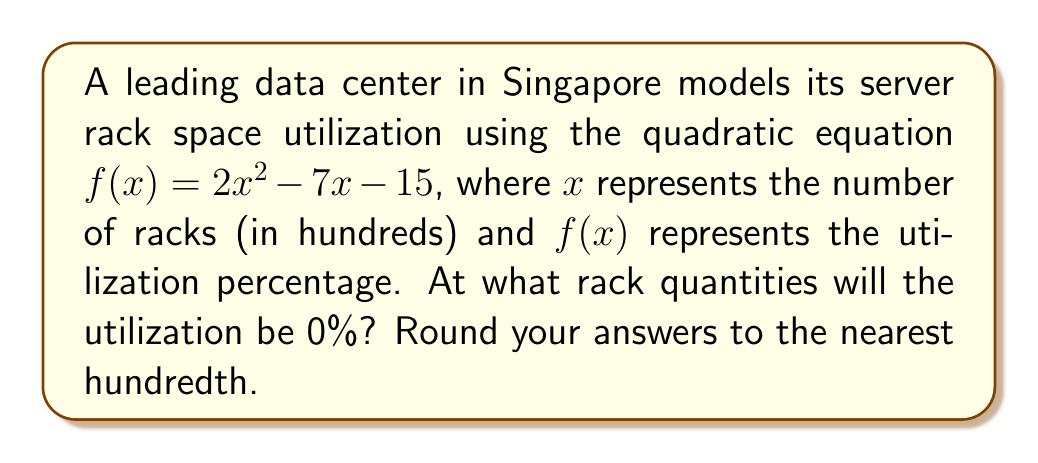Provide a solution to this math problem. To find the rack quantities where utilization is 0%, we need to find the roots of the quadratic equation $f(x) = 0$.

Step 1: Set up the equation
$$2x^2 - 7x - 15 = 0$$

Step 2: Use the quadratic formula $x = \frac{-b \pm \sqrt{b^2 - 4ac}}{2a}$
Where $a = 2$, $b = -7$, and $c = -15$

Step 3: Substitute into the quadratic formula
$$x = \frac{-(-7) \pm \sqrt{(-7)^2 - 4(2)(-15)}}{2(2)}$$

Step 4: Simplify
$$x = \frac{7 \pm \sqrt{49 + 120}}{4} = \frac{7 \pm \sqrt{169}}{4} = \frac{7 \pm 13}{4}$$

Step 5: Calculate the two roots
$$x_1 = \frac{7 + 13}{4} = \frac{20}{4} = 5$$
$$x_2 = \frac{7 - 13}{4} = -\frac{6}{4} = -1.5$$

Step 6: Interpret the results
The positive root (5) represents 500 racks, while the negative root (-1.5) is not physically meaningful in this context.
Answer: 500 racks 